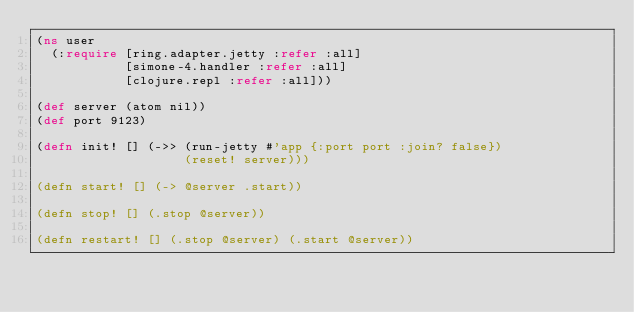<code> <loc_0><loc_0><loc_500><loc_500><_Clojure_>(ns user
  (:require [ring.adapter.jetty :refer :all]
            [simone-4.handler :refer :all]
            [clojure.repl :refer :all]))

(def server (atom nil))
(def port 9123)

(defn init! [] (->> (run-jetty #'app {:port port :join? false})
                    (reset! server)))

(defn start! [] (-> @server .start))

(defn stop! [] (.stop @server))

(defn restart! [] (.stop @server) (.start @server))

</code> 